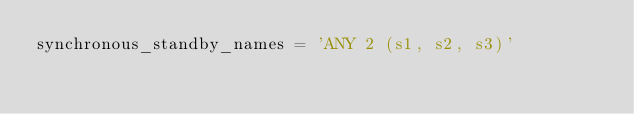<code> <loc_0><loc_0><loc_500><loc_500><_SQL_>synchronous_standby_names = 'ANY 2 (s1, s2, s3)'
</code> 